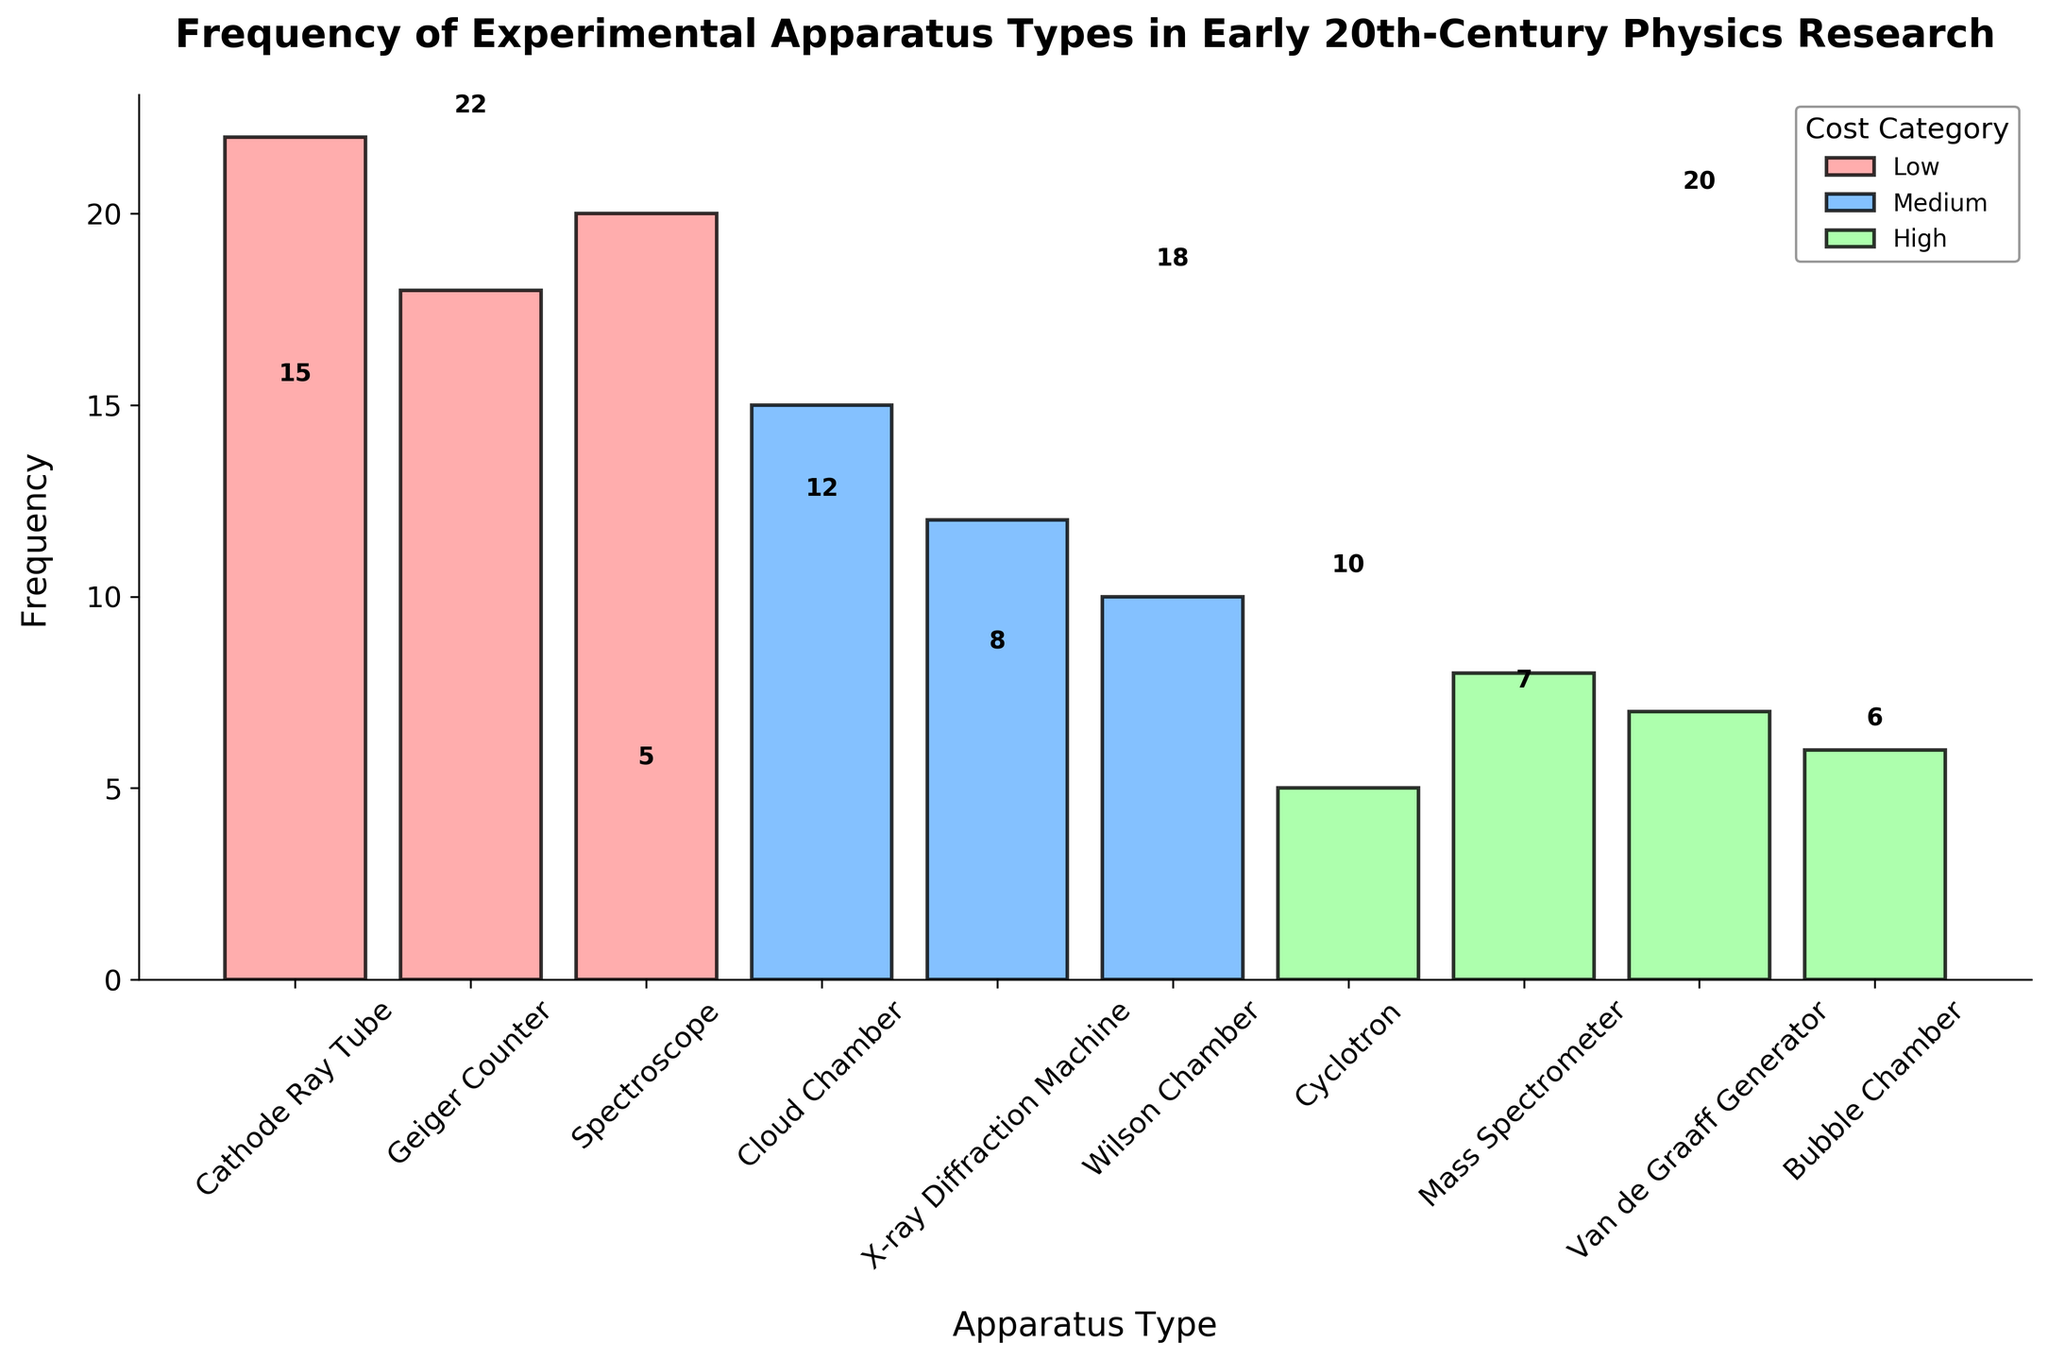Which apparatus type has the highest frequency of use? Analyze the heights of each bar in the histogram. The Cathode Ray Tube has the highest bar corresponding to the highest frequency.
Answer: Cathode Ray Tube What's the frequency of the Geiger Counter? Locate the bar for the Geiger Counter and read its height, which represents its frequency. The Geiger Counter has a frequency of 18.
Answer: 18 How many apparatus types belong to the High cost category? Count the number of bars colored in green (assumed to represent High cost) based on the color legend. There are four such bars.
Answer: 4 What is the combined frequency of apparatus types in the Medium cost category? Sum the heights (frequencies) of the bars in the Medium cost category: Cloud Chamber (15) + X-ray Diffraction Machine (12) + Wilson Chamber (10). Thus, 15 + 12 + 10 = 37.
Answer: 37 Which high-cost apparatus type is used the least frequently? Look at the heights of the green bars and identify the smallest one. The green bar with the smallest height belongs to the Bubble Chamber.
Answer: Bubble Chamber Between the Geiger Counter and the Spectroscope, which one is used more frequently? Compare the heights of the bars representing the Geiger Counter and the Spectroscope. The bar for the Spectroscope is taller than the bar for the Geiger Counter.
Answer: Spectroscope What is the difference in frequency between the Cyclotron and the Mass Spectrometer? Subtract the height of the Cyclotron bar from the height of the Mass Spectrometer bar. For the Cyclotron, it's 5, and for the Mass Spectrometer, it's 8. Thus, 8 - 5 = 3.
Answer: 3 What cost category is the Cloud Chamber in, and what is its frequency? Identify the color of the Cloud Chamber bar to determine its cost category (blue for Medium). Then read its height for frequency, which is 15.
Answer: Medium, 15 Which cost category has the highest total frequency? Sum the frequencies for each cost category and compare them. Low: Cathode Ray Tube (22) + Geiger Counter (18) + Spectroscope (20) = 60; Medium: Cloud Chamber (15) + X-ray Diffraction Machine (12) + Wilson Chamber (10) = 37; High: Cyclotron (5) + Mass Spectrometer (8) + Van de Graaff Generator (7) + Bubble Chamber (6) = 26. The Low category has the highest total frequency.
Answer: Low What is the average frequency of apparatus types in the Low cost category? Calculate the sum of the frequencies for the Low cost category and divide by the number of apparatus types: (22 + 18 + 20) / 3 = 60 / 3 = 20.
Answer: 20 